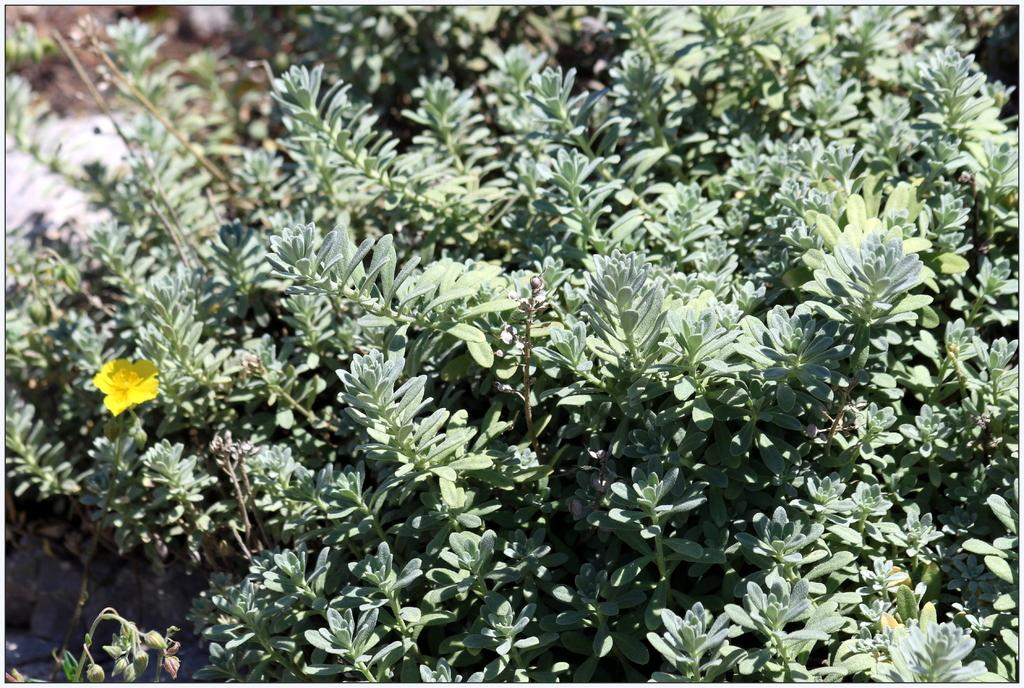What type of living organisms can be seen in the image? Plants can be seen in the image. Can you describe the specific plant on the left side of the image? There is a flower on the left side of the image. What is the best route to take to reach the juice in the image? There is no juice present in the image, so there is no route to reach it. 